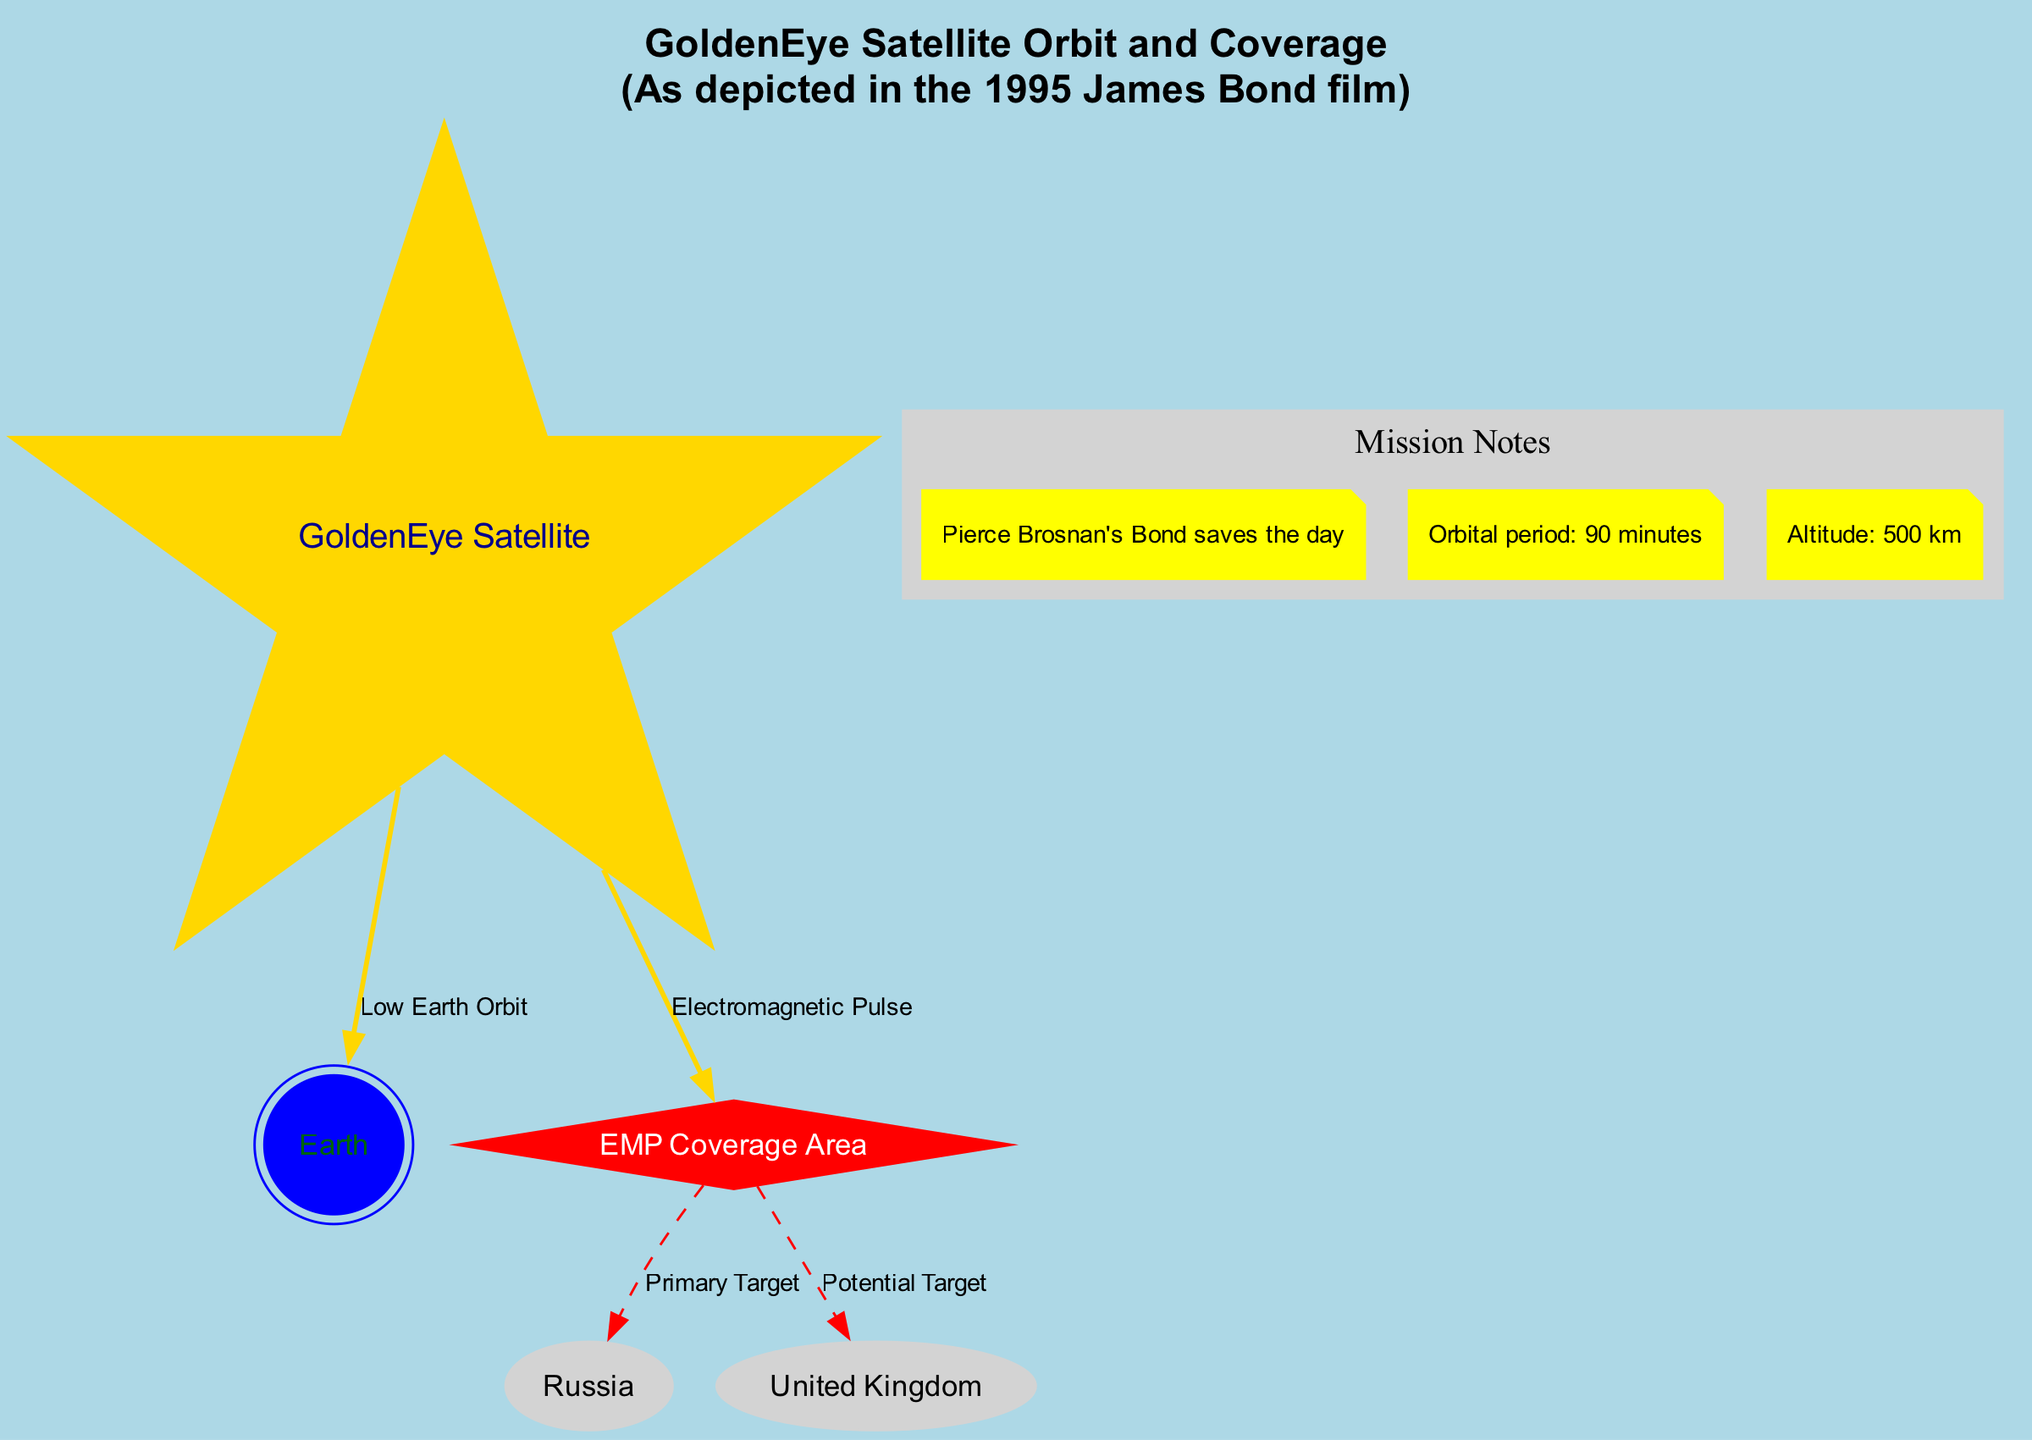What is the altitude of the GoldenEye satellite? The diagram includes a note that specifies the altitude of the GoldenEye satellite as 500 km. This information is directly provided in one of the notes accompanying the visual representation.
Answer: 500 km What is the primary target of the EMP? Based on the diagram, the EMP coverage area indicates Russia as the primary target. This is shown through a dashed edge leading to the Russia node from the EMP node.
Answer: Russia How many nodes are present in the diagram? By counting the unique nodes listed in the diagram, we have five: GoldenEye Satellite, Earth, Russia, United Kingdom, and EMP Coverage Area. This is a straightforward counting of the nodes involved.
Answer: 5 What is the orbital period of the GoldenEye satellite? The diagram contains a note stating that the orbital period of the GoldenEye satellite is 90 minutes. This information is directly taken from the notes provided in the diagram.
Answer: 90 minutes Which area is a potential target of the EMP? The diagram shows the United Kingdom as a potential target of the EMP. This is illustrated by a dashed line connecting the EMP node to the node representing the United Kingdom.
Answer: United Kingdom What type of orbit does the GoldenEye satellite have? According to the edge relationship shown in the diagram, the satellite has a Low Earth Orbit. This is indicated by the edge labeled “Low Earth Orbit” connecting the GoldenEye node to the Earth node.
Answer: Low Earth Orbit What is the color of the GoldenEye satellite node in the diagram? The GoldenEye satellite node is colored gold, as specified in the custom styles of the diagram where the GoldenEye is specifically set to have a gold color and a star shape.
Answer: Gold What is the coverage area represented in the diagram? The diagram highlights the EMP coverage area, indicated by the dashed connection to Russia and the United Kingdom, emphasizing the scope of the electromagnetic pulse.
Answer: EMP Coverage Area How long does it take for the GoldenEye satellite to complete one orbit? The note in the diagram specifies that it takes 90 minutes for the GoldenEye satellite to complete one orbit around the Earth. This is a clear statement from the note section explaining the orbital period.
Answer: 90 minutes 